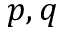<formula> <loc_0><loc_0><loc_500><loc_500>p , q</formula> 